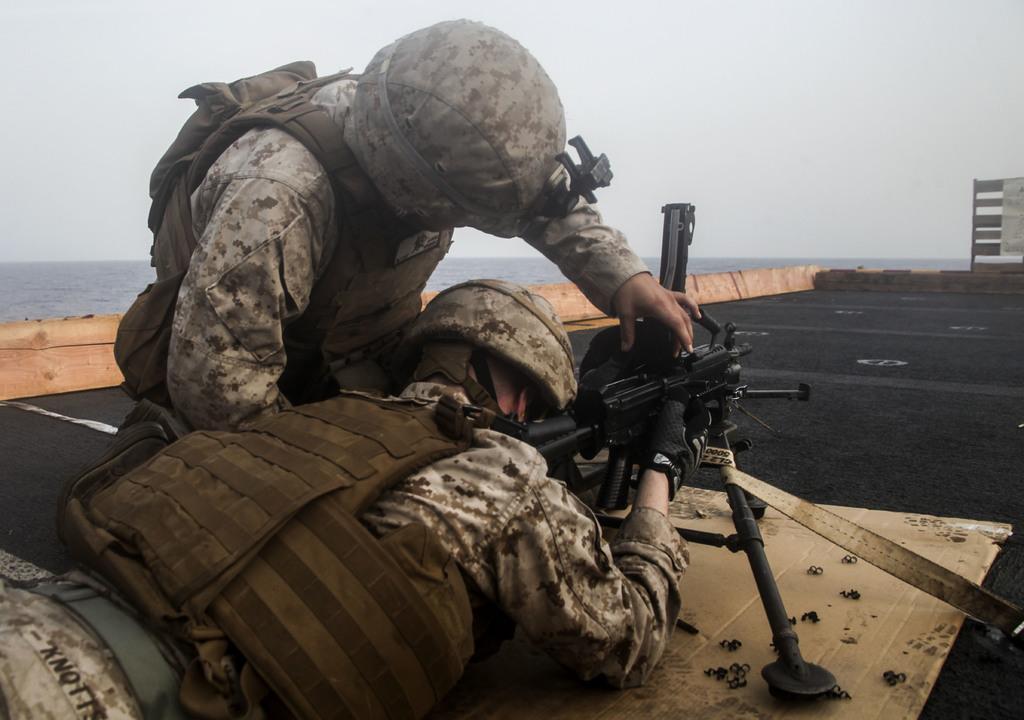Could you give a brief overview of what you see in this image? In the center of the image there are two people wearing a uniform and using a weapon. In the background of the image there is water. There is sky. 